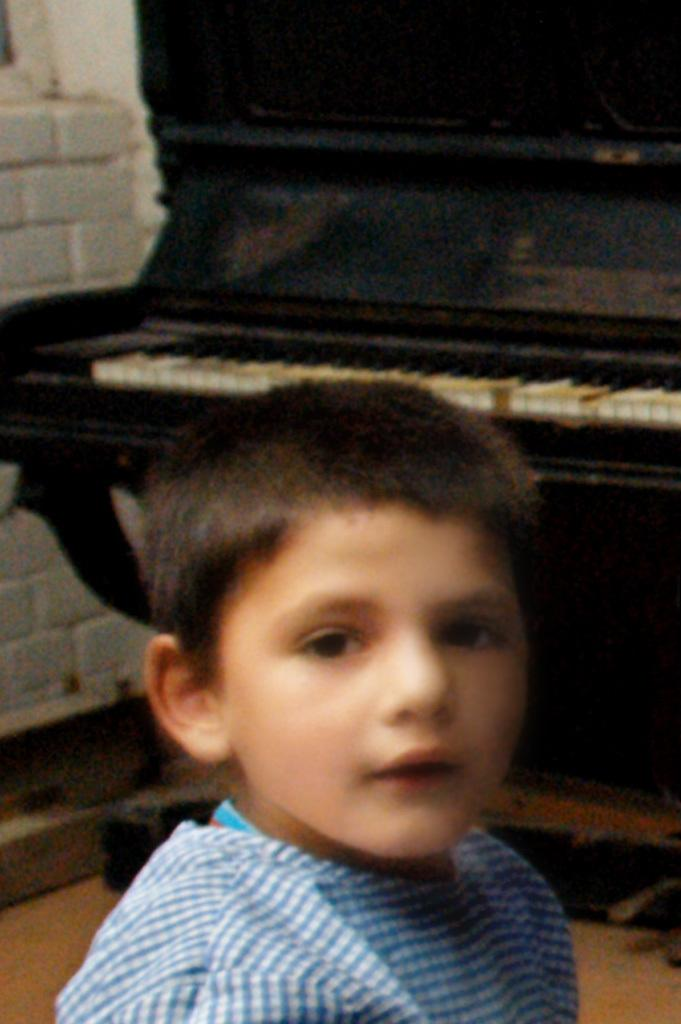Who is present in the image? There is a boy in the image. What is the boy's expression? The boy is smiling. What can be seen in the background of the image? There is a piano and a wall in the background of the image. What type of attraction is the boy visiting in the image? There is no indication of an attraction in the image; it simply features a boy smiling with a piano and a wall in the background. 